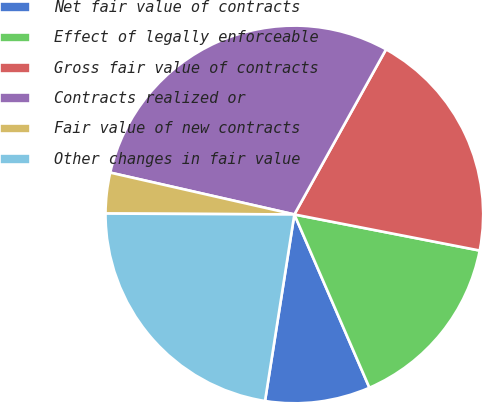Convert chart. <chart><loc_0><loc_0><loc_500><loc_500><pie_chart><fcel>Net fair value of contracts<fcel>Effect of legally enforceable<fcel>Gross fair value of contracts<fcel>Contracts realized or<fcel>Fair value of new contracts<fcel>Other changes in fair value<nl><fcel>8.99%<fcel>15.43%<fcel>19.99%<fcel>29.51%<fcel>3.48%<fcel>22.59%<nl></chart> 